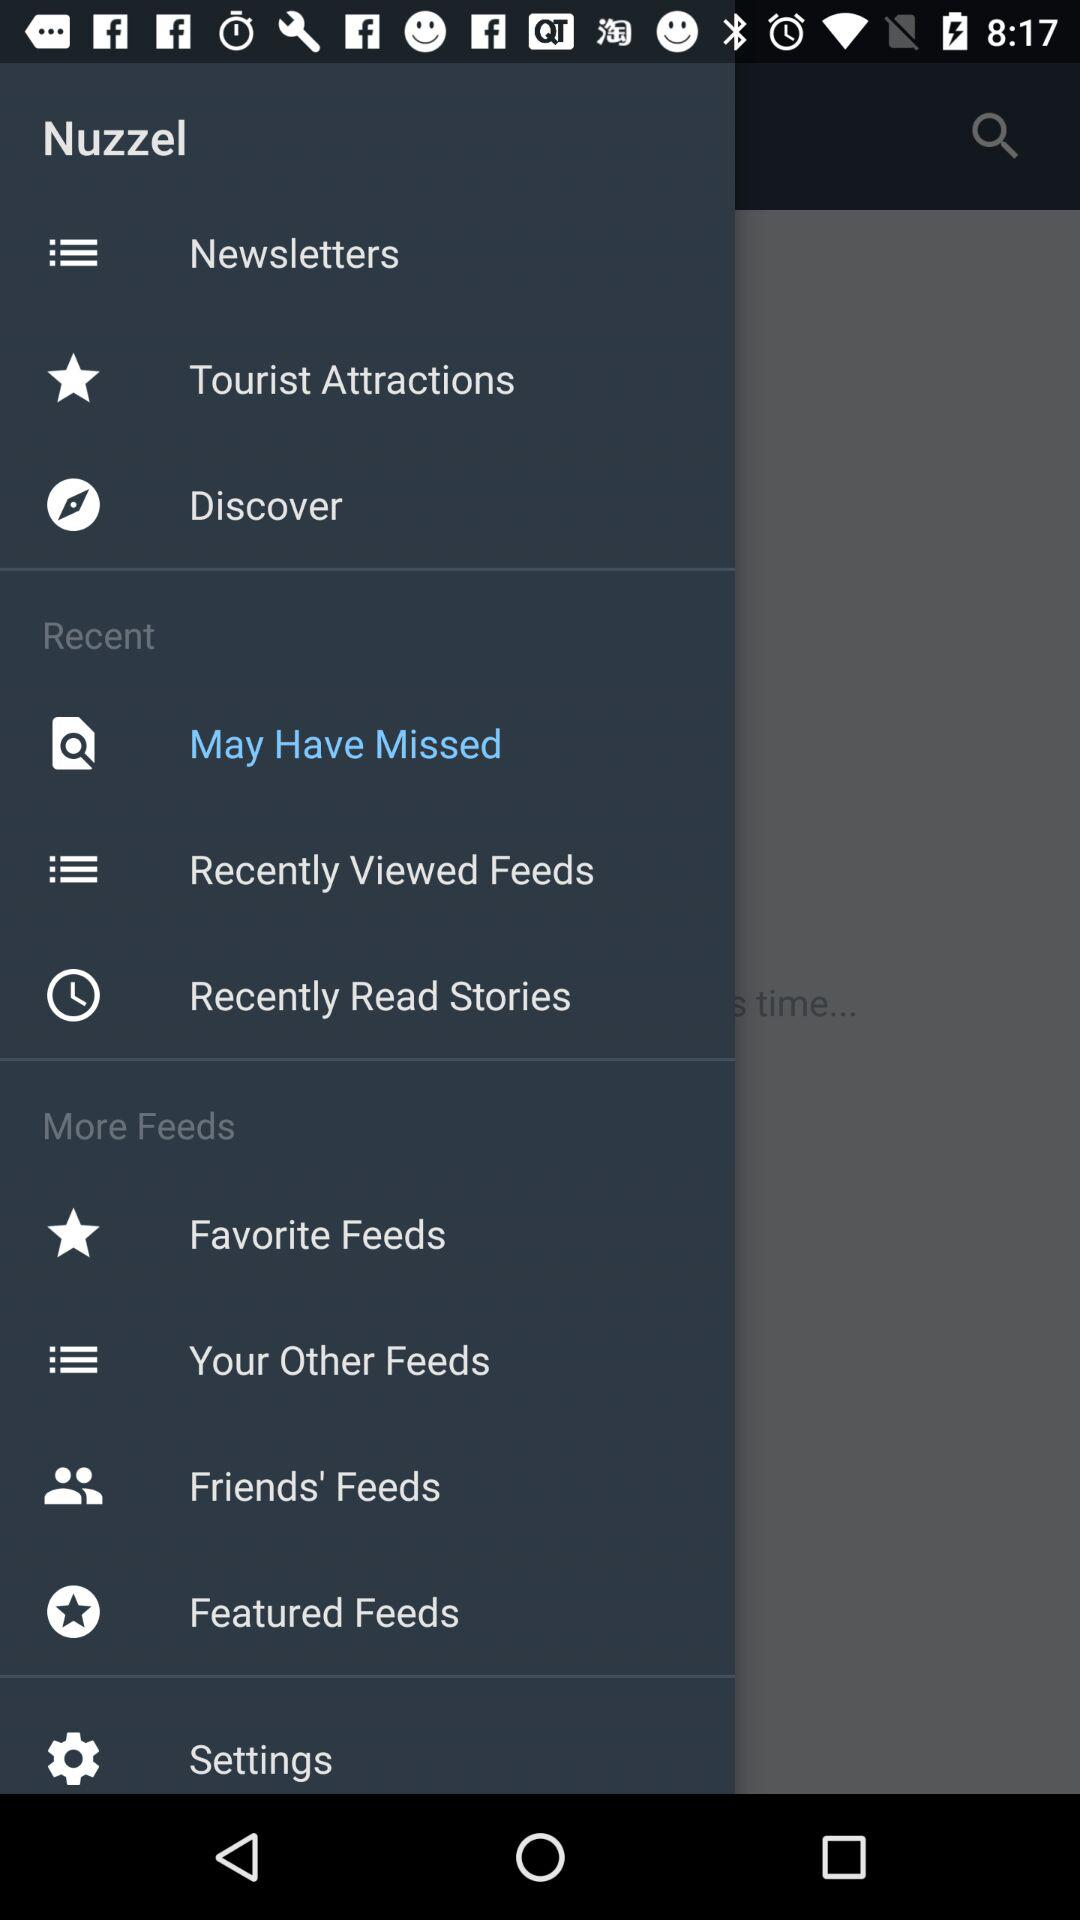Which item has been selected? The item that has been selected is "May Have Missed". 